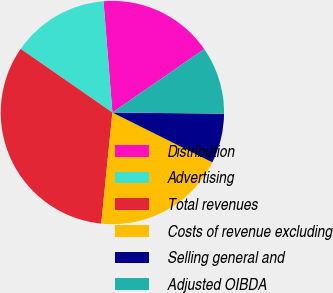Convert chart to OTSL. <chart><loc_0><loc_0><loc_500><loc_500><pie_chart><fcel>Distribution<fcel>Advertising<fcel>Total revenues<fcel>Costs of revenue excluding<fcel>Selling general and<fcel>Adjusted OIBDA<nl><fcel>16.65%<fcel>14.07%<fcel>33.06%<fcel>19.24%<fcel>7.2%<fcel>9.78%<nl></chart> 